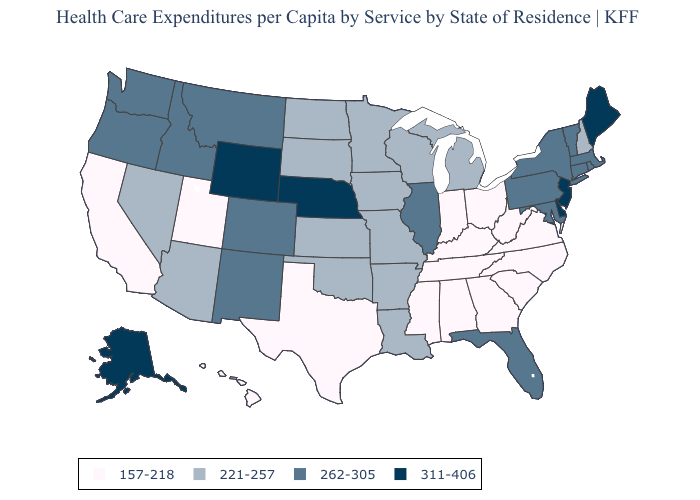Name the states that have a value in the range 262-305?
Give a very brief answer. Colorado, Connecticut, Florida, Idaho, Illinois, Maryland, Massachusetts, Montana, New Mexico, New York, Oregon, Pennsylvania, Rhode Island, Vermont, Washington. Name the states that have a value in the range 262-305?
Write a very short answer. Colorado, Connecticut, Florida, Idaho, Illinois, Maryland, Massachusetts, Montana, New Mexico, New York, Oregon, Pennsylvania, Rhode Island, Vermont, Washington. What is the lowest value in the USA?
Keep it brief. 157-218. Name the states that have a value in the range 311-406?
Answer briefly. Alaska, Delaware, Maine, Nebraska, New Jersey, Wyoming. What is the lowest value in states that border Ohio?
Keep it brief. 157-218. Name the states that have a value in the range 262-305?
Short answer required. Colorado, Connecticut, Florida, Idaho, Illinois, Maryland, Massachusetts, Montana, New Mexico, New York, Oregon, Pennsylvania, Rhode Island, Vermont, Washington. Name the states that have a value in the range 221-257?
Quick response, please. Arizona, Arkansas, Iowa, Kansas, Louisiana, Michigan, Minnesota, Missouri, Nevada, New Hampshire, North Dakota, Oklahoma, South Dakota, Wisconsin. What is the value of Mississippi?
Answer briefly. 157-218. What is the highest value in the MidWest ?
Write a very short answer. 311-406. Name the states that have a value in the range 311-406?
Answer briefly. Alaska, Delaware, Maine, Nebraska, New Jersey, Wyoming. Does the map have missing data?
Give a very brief answer. No. Among the states that border Nebraska , does Colorado have the highest value?
Short answer required. No. Among the states that border New Hampshire , does Maine have the highest value?
Concise answer only. Yes. What is the value of North Carolina?
Be succinct. 157-218. What is the highest value in the USA?
Be succinct. 311-406. 